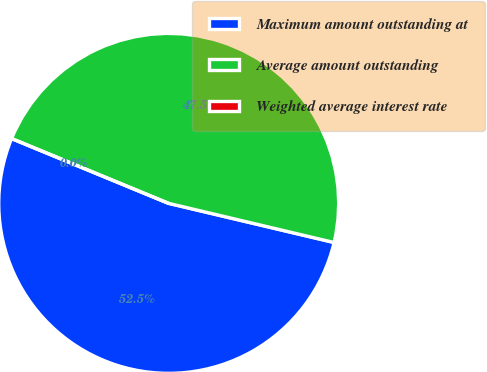<chart> <loc_0><loc_0><loc_500><loc_500><pie_chart><fcel>Maximum amount outstanding at<fcel>Average amount outstanding<fcel>Weighted average interest rate<nl><fcel>52.53%<fcel>47.47%<fcel>0.0%<nl></chart> 